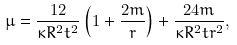Convert formula to latex. <formula><loc_0><loc_0><loc_500><loc_500>\mu = \frac { 1 2 } { \kappa R ^ { 2 } t ^ { 2 } } \left ( 1 + \frac { 2 m } { r } \right ) + \frac { 2 4 m } { \kappa R ^ { 2 } t r ^ { 2 } } ,</formula> 